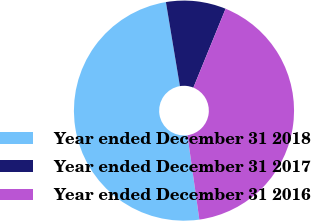<chart> <loc_0><loc_0><loc_500><loc_500><pie_chart><fcel>Year ended December 31 2018<fcel>Year ended December 31 2017<fcel>Year ended December 31 2016<nl><fcel>49.6%<fcel>8.8%<fcel>41.6%<nl></chart> 